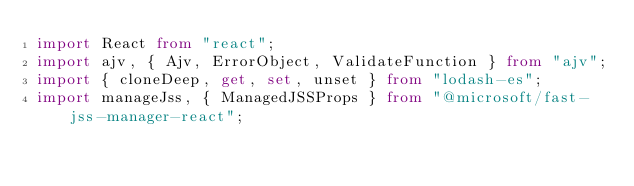Convert code to text. <code><loc_0><loc_0><loc_500><loc_500><_TypeScript_>import React from "react";
import ajv, { Ajv, ErrorObject, ValidateFunction } from "ajv";
import { cloneDeep, get, set, unset } from "lodash-es";
import manageJss, { ManagedJSSProps } from "@microsoft/fast-jss-manager-react";</code> 